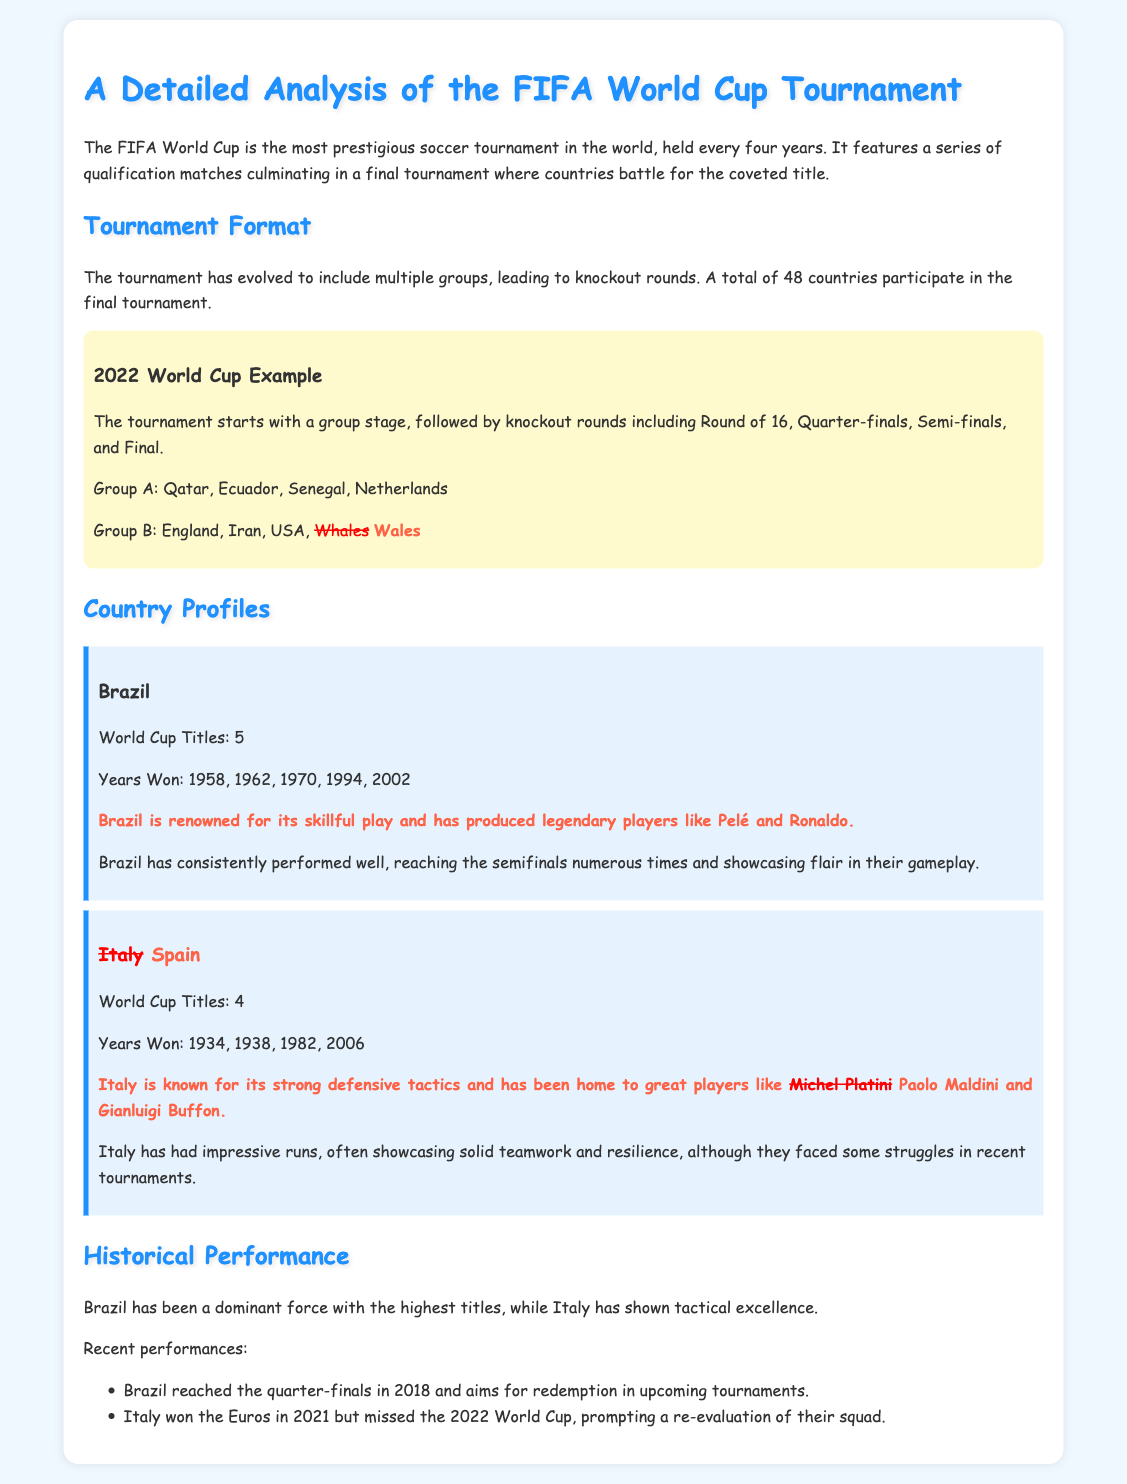What is the title of the document? The title of the document is found in the <title> tag and the main heading, which indicates the focus on a detailed analysis of the FIFA World Cup tournament.
Answer: A Detailed Analysis of the FIFA World Cup Tournament How many World Cup titles does Brazil have? The number of World Cup titles won by Brazil is explicitly stated in the section about its country profile.
Answer: 5 In which years did Brazil win the World Cup? The document lists the specific years that Brazil won its titles, which are mentioned in the country profile section.
Answer: 1958, 1962, 1970, 1994, 2002 What is Italy known for according to the document? The document describes Italy's style of play and tactical approach, providing insight into its reputation in the sport.
Answer: Strong defensive tactics How many times has Italy won the World Cup? This information is provided in the country profile about Italy, specifying the total number of titles.
Answer: 4 What was Brazil's recent performance in the 2018 World Cup? This detail is mentioned in the historical performance section, summarizing Brazil's results in that tournament.
Answer: Reached the quarter-finals Which tournament did Italy win in 2021? The document states Italy's success in 2021 in the context of their recent performances.
Answer: Euros What has prompted a re-evaluation of Italy's squad? The note mentions Italy's absence from a recent tournament as the reason for this re-evaluation.
Answer: Missed the 2022 World Cup What type of play does Brazil showcase? The document highlights Brazil's gameplay style, focusing on their strengths in soccer.
Answer: Flair 